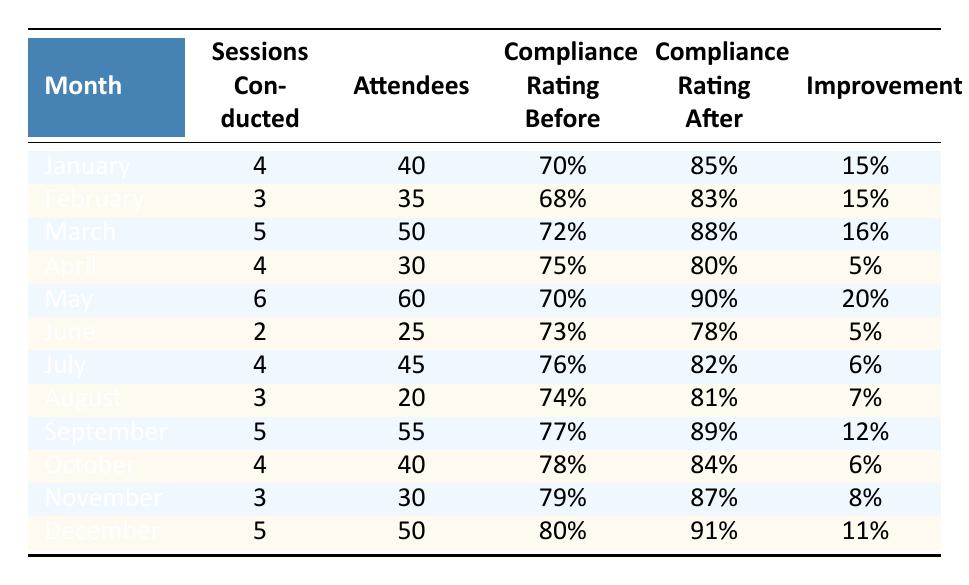What's the total number of training sessions conducted in the year? By adding the number of sessions conducted each month: 4 + 3 + 5 + 4 + 6 + 2 + 4 + 3 + 5 + 4 + 3 + 5 = 57.
Answer: 57 Which month had the highest compliance rating after the training sessions? Reviewing the compliance ratings after training for each month, December has the highest rating at 91%.
Answer: December What is the average improvement in compliance ratings across all months? To calculate the average improvement, sum all the improvements: (15 + 15 + 16 + 5 + 20 + 5 + 6 + 7 + 12 + 6 + 8 + 11 =  126) and divide by the number of months (12). So, 126 / 12 = 10.5.
Answer: 10.5 Did all months see an improvement in compliance ratings? By checking each month's improvement, all months show a positive change, confirming that there was improvement every month.
Answer: Yes Which month had the lowest number of attendees at training sessions? Comparing across the table, June had the lowest number of attendees with 25.
Answer: June What was the compliance rating before training sessions in March? Directly referencing the table, the compliance rating before training in March was 72%.
Answer: 72% If we look at the months that had more than 4 sessions, what was the average compliance rating after those sessions? The months with more than 4 training sessions are January (85%), March (88%), May (90%), September (89%), and December (91%). Their average is (85 + 88 + 90 + 89 + 91) / 5 = 87.
Answer: 87 In which month was the improvement the least? The improvements for each month show the least improvement was in April with an increase of only 5%.
Answer: April Which month had more attendees than sessions conducted? To find this, we compare each month: May (60 attendees, 6 sessions), March (50 attendees, 5 sessions), September (55 attendees, 5 sessions), and January (40 attendees, 4 sessions) all have more attendees than sessions.
Answer: January, March, May, September What is the range of compliance ratings before training sessions throughout the year? By assessing the compliance ratings before training, the highest value was 80% in December, and the lowest was 68% in February; thus, the range is 80% - 68% = 12%.
Answer: 12% 